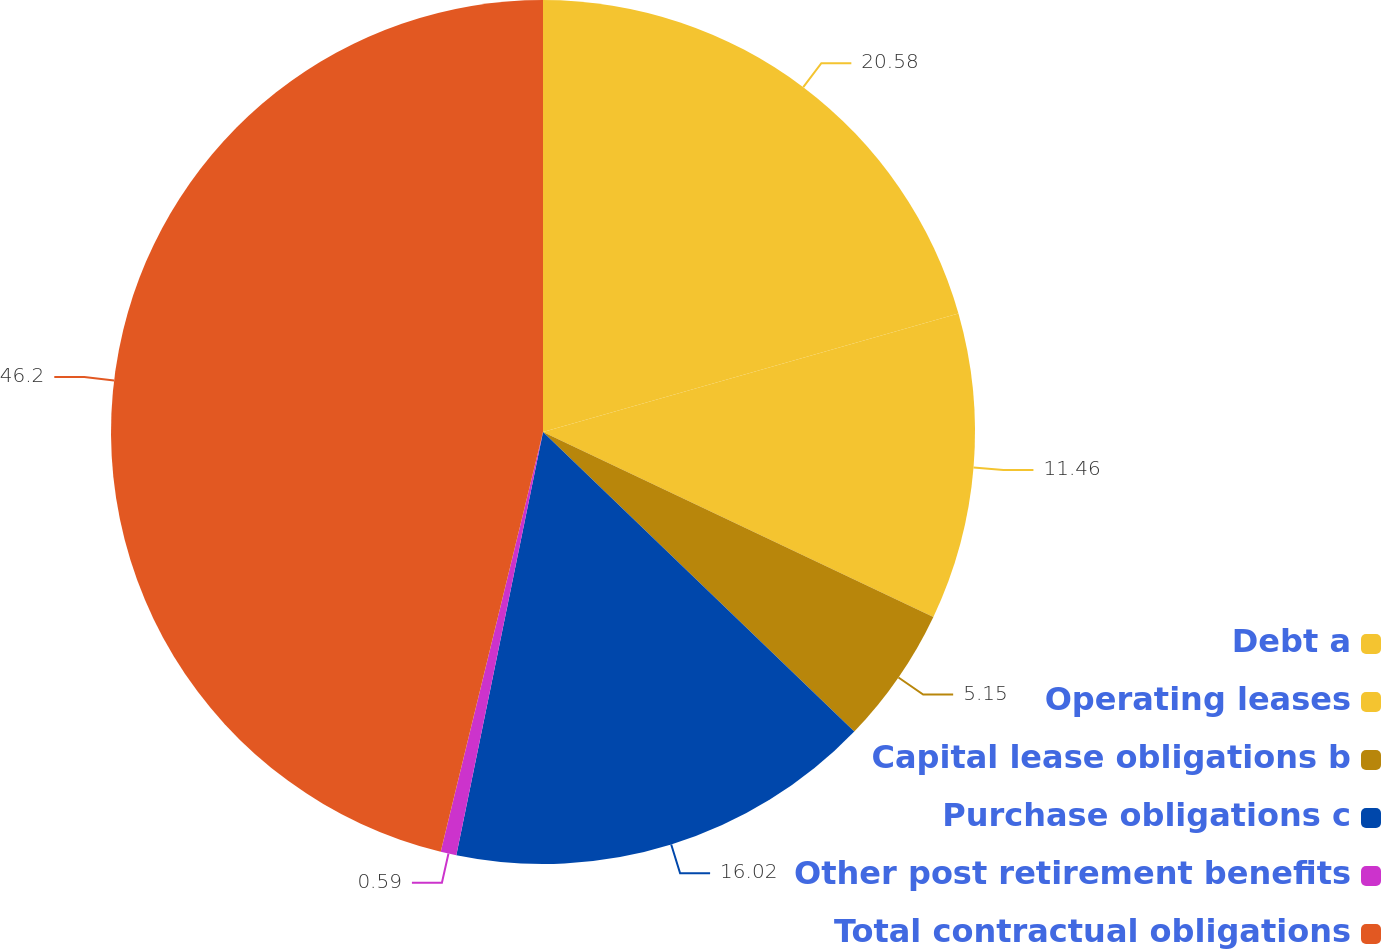Convert chart to OTSL. <chart><loc_0><loc_0><loc_500><loc_500><pie_chart><fcel>Debt a<fcel>Operating leases<fcel>Capital lease obligations b<fcel>Purchase obligations c<fcel>Other post retirement benefits<fcel>Total contractual obligations<nl><fcel>20.58%<fcel>11.46%<fcel>5.15%<fcel>16.02%<fcel>0.59%<fcel>46.19%<nl></chart> 